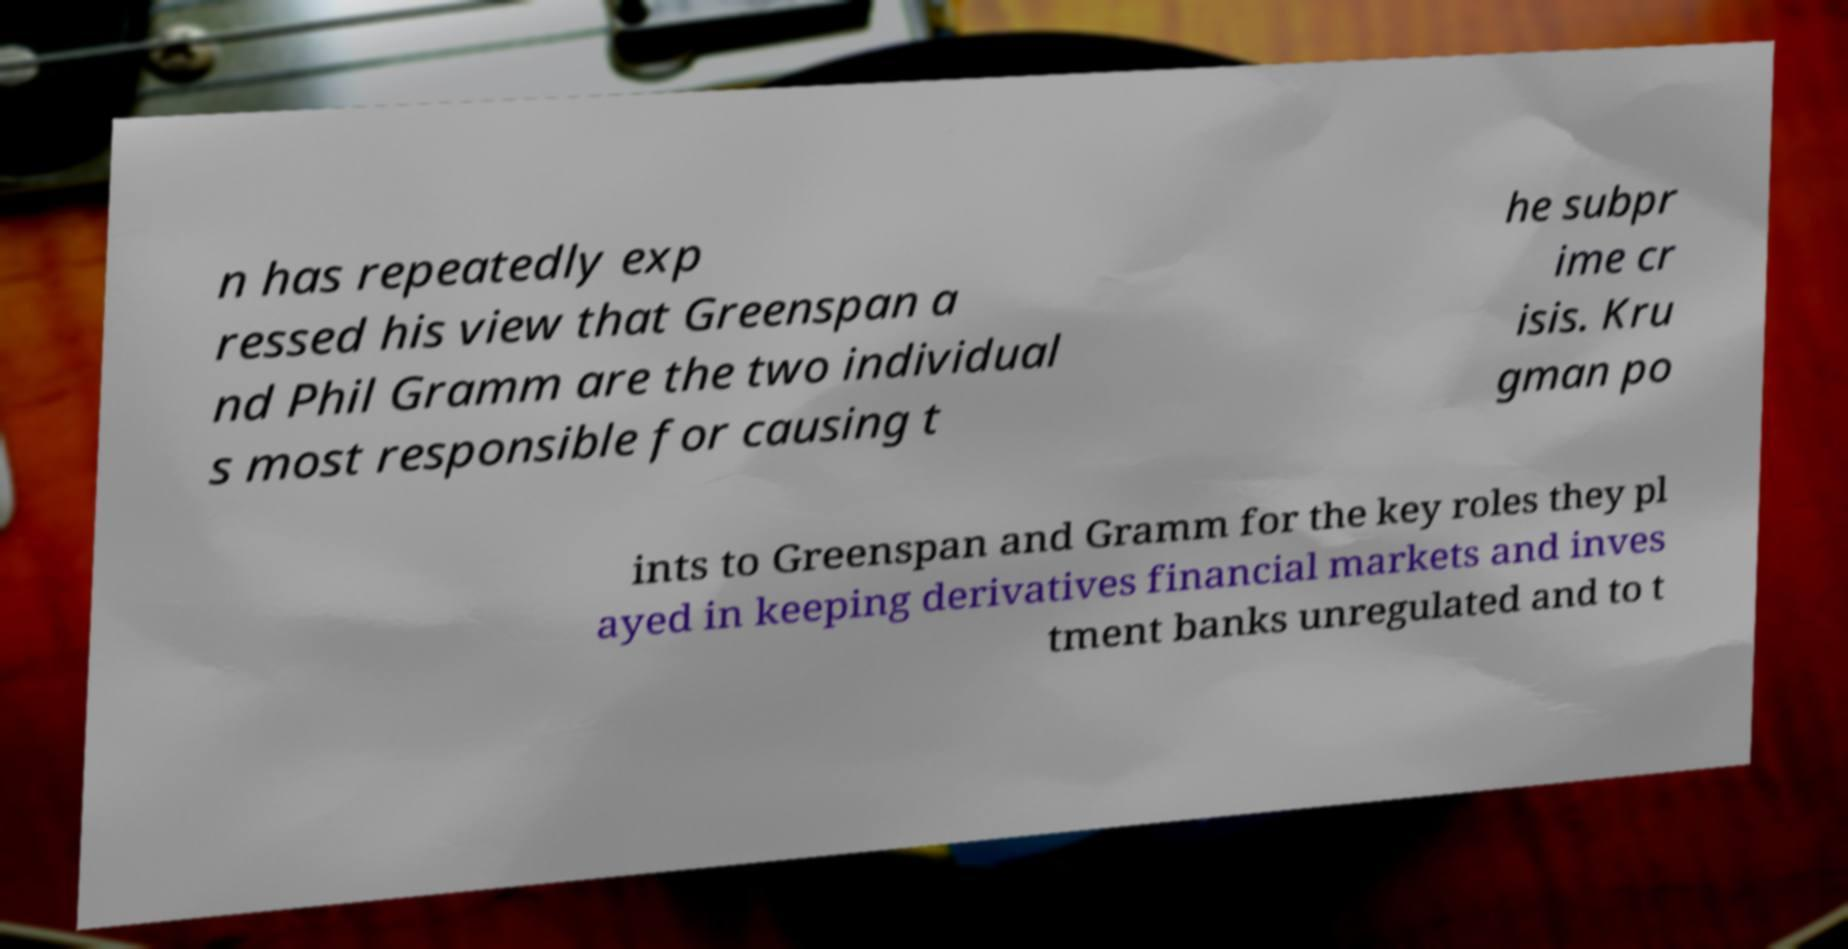Could you extract and type out the text from this image? n has repeatedly exp ressed his view that Greenspan a nd Phil Gramm are the two individual s most responsible for causing t he subpr ime cr isis. Kru gman po ints to Greenspan and Gramm for the key roles they pl ayed in keeping derivatives financial markets and inves tment banks unregulated and to t 